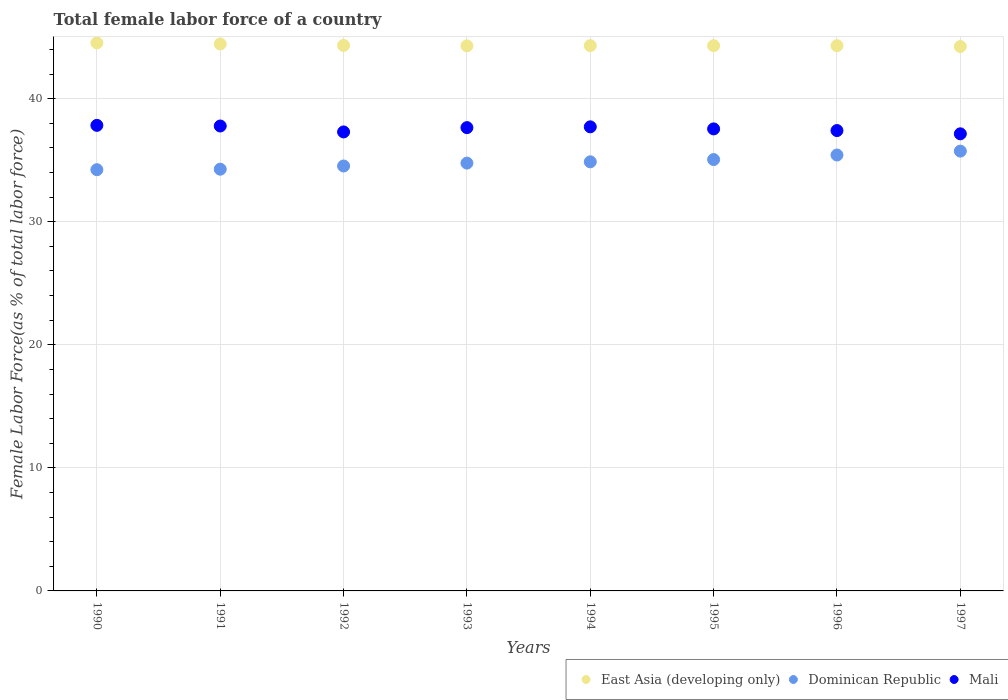How many different coloured dotlines are there?
Provide a succinct answer. 3. Is the number of dotlines equal to the number of legend labels?
Make the answer very short. Yes. What is the percentage of female labor force in East Asia (developing only) in 1993?
Offer a very short reply. 44.29. Across all years, what is the maximum percentage of female labor force in Mali?
Your answer should be very brief. 37.83. Across all years, what is the minimum percentage of female labor force in Mali?
Provide a succinct answer. 37.14. In which year was the percentage of female labor force in Mali minimum?
Your response must be concise. 1997. What is the total percentage of female labor force in Dominican Republic in the graph?
Keep it short and to the point. 278.86. What is the difference between the percentage of female labor force in Mali in 1992 and that in 1996?
Give a very brief answer. -0.11. What is the difference between the percentage of female labor force in East Asia (developing only) in 1991 and the percentage of female labor force in Dominican Republic in 1995?
Provide a short and direct response. 9.39. What is the average percentage of female labor force in Dominican Republic per year?
Your answer should be compact. 34.86. In the year 1996, what is the difference between the percentage of female labor force in Mali and percentage of female labor force in East Asia (developing only)?
Your response must be concise. -6.9. In how many years, is the percentage of female labor force in Dominican Republic greater than 40 %?
Your answer should be compact. 0. What is the ratio of the percentage of female labor force in East Asia (developing only) in 1991 to that in 1995?
Your response must be concise. 1. Is the percentage of female labor force in East Asia (developing only) in 1992 less than that in 1995?
Keep it short and to the point. No. Is the difference between the percentage of female labor force in Mali in 1990 and 1997 greater than the difference between the percentage of female labor force in East Asia (developing only) in 1990 and 1997?
Provide a short and direct response. Yes. What is the difference between the highest and the second highest percentage of female labor force in Mali?
Keep it short and to the point. 0.05. What is the difference between the highest and the lowest percentage of female labor force in Mali?
Give a very brief answer. 0.69. In how many years, is the percentage of female labor force in East Asia (developing only) greater than the average percentage of female labor force in East Asia (developing only) taken over all years?
Give a very brief answer. 2. Is it the case that in every year, the sum of the percentage of female labor force in East Asia (developing only) and percentage of female labor force in Mali  is greater than the percentage of female labor force in Dominican Republic?
Your answer should be compact. Yes. Is the percentage of female labor force in East Asia (developing only) strictly greater than the percentage of female labor force in Mali over the years?
Your answer should be compact. Yes. Is the percentage of female labor force in Mali strictly less than the percentage of female labor force in East Asia (developing only) over the years?
Make the answer very short. Yes. What is the difference between two consecutive major ticks on the Y-axis?
Offer a terse response. 10. Where does the legend appear in the graph?
Provide a short and direct response. Bottom right. How many legend labels are there?
Provide a succinct answer. 3. How are the legend labels stacked?
Offer a terse response. Horizontal. What is the title of the graph?
Provide a short and direct response. Total female labor force of a country. What is the label or title of the Y-axis?
Ensure brevity in your answer.  Female Labor Force(as % of total labor force). What is the Female Labor Force(as % of total labor force) in East Asia (developing only) in 1990?
Your response must be concise. 44.53. What is the Female Labor Force(as % of total labor force) in Dominican Republic in 1990?
Provide a succinct answer. 34.23. What is the Female Labor Force(as % of total labor force) of Mali in 1990?
Your answer should be very brief. 37.83. What is the Female Labor Force(as % of total labor force) of East Asia (developing only) in 1991?
Make the answer very short. 44.44. What is the Female Labor Force(as % of total labor force) of Dominican Republic in 1991?
Your answer should be very brief. 34.27. What is the Female Labor Force(as % of total labor force) of Mali in 1991?
Provide a short and direct response. 37.78. What is the Female Labor Force(as % of total labor force) in East Asia (developing only) in 1992?
Provide a short and direct response. 44.33. What is the Female Labor Force(as % of total labor force) in Dominican Republic in 1992?
Keep it short and to the point. 34.53. What is the Female Labor Force(as % of total labor force) of Mali in 1992?
Offer a very short reply. 37.3. What is the Female Labor Force(as % of total labor force) in East Asia (developing only) in 1993?
Offer a very short reply. 44.29. What is the Female Labor Force(as % of total labor force) in Dominican Republic in 1993?
Make the answer very short. 34.76. What is the Female Labor Force(as % of total labor force) of Mali in 1993?
Offer a terse response. 37.65. What is the Female Labor Force(as % of total labor force) in East Asia (developing only) in 1994?
Keep it short and to the point. 44.31. What is the Female Labor Force(as % of total labor force) of Dominican Republic in 1994?
Provide a short and direct response. 34.87. What is the Female Labor Force(as % of total labor force) in Mali in 1994?
Ensure brevity in your answer.  37.71. What is the Female Labor Force(as % of total labor force) in East Asia (developing only) in 1995?
Keep it short and to the point. 44.3. What is the Female Labor Force(as % of total labor force) in Dominican Republic in 1995?
Your response must be concise. 35.05. What is the Female Labor Force(as % of total labor force) of Mali in 1995?
Offer a very short reply. 37.54. What is the Female Labor Force(as % of total labor force) of East Asia (developing only) in 1996?
Make the answer very short. 44.3. What is the Female Labor Force(as % of total labor force) of Dominican Republic in 1996?
Make the answer very short. 35.42. What is the Female Labor Force(as % of total labor force) of Mali in 1996?
Give a very brief answer. 37.41. What is the Female Labor Force(as % of total labor force) in East Asia (developing only) in 1997?
Provide a succinct answer. 44.24. What is the Female Labor Force(as % of total labor force) of Dominican Republic in 1997?
Provide a short and direct response. 35.74. What is the Female Labor Force(as % of total labor force) in Mali in 1997?
Provide a succinct answer. 37.14. Across all years, what is the maximum Female Labor Force(as % of total labor force) of East Asia (developing only)?
Your answer should be very brief. 44.53. Across all years, what is the maximum Female Labor Force(as % of total labor force) of Dominican Republic?
Make the answer very short. 35.74. Across all years, what is the maximum Female Labor Force(as % of total labor force) in Mali?
Make the answer very short. 37.83. Across all years, what is the minimum Female Labor Force(as % of total labor force) of East Asia (developing only)?
Keep it short and to the point. 44.24. Across all years, what is the minimum Female Labor Force(as % of total labor force) in Dominican Republic?
Provide a short and direct response. 34.23. Across all years, what is the minimum Female Labor Force(as % of total labor force) of Mali?
Give a very brief answer. 37.14. What is the total Female Labor Force(as % of total labor force) of East Asia (developing only) in the graph?
Your answer should be compact. 354.74. What is the total Female Labor Force(as % of total labor force) in Dominican Republic in the graph?
Give a very brief answer. 278.86. What is the total Female Labor Force(as % of total labor force) of Mali in the graph?
Provide a succinct answer. 300.35. What is the difference between the Female Labor Force(as % of total labor force) of East Asia (developing only) in 1990 and that in 1991?
Keep it short and to the point. 0.09. What is the difference between the Female Labor Force(as % of total labor force) in Dominican Republic in 1990 and that in 1991?
Keep it short and to the point. -0.04. What is the difference between the Female Labor Force(as % of total labor force) in Mali in 1990 and that in 1991?
Your response must be concise. 0.05. What is the difference between the Female Labor Force(as % of total labor force) of East Asia (developing only) in 1990 and that in 1992?
Provide a short and direct response. 0.2. What is the difference between the Female Labor Force(as % of total labor force) in Dominican Republic in 1990 and that in 1992?
Your answer should be compact. -0.3. What is the difference between the Female Labor Force(as % of total labor force) of Mali in 1990 and that in 1992?
Your response must be concise. 0.53. What is the difference between the Female Labor Force(as % of total labor force) of East Asia (developing only) in 1990 and that in 1993?
Offer a very short reply. 0.24. What is the difference between the Female Labor Force(as % of total labor force) in Dominican Republic in 1990 and that in 1993?
Ensure brevity in your answer.  -0.54. What is the difference between the Female Labor Force(as % of total labor force) in Mali in 1990 and that in 1993?
Provide a succinct answer. 0.18. What is the difference between the Female Labor Force(as % of total labor force) of East Asia (developing only) in 1990 and that in 1994?
Your answer should be very brief. 0.22. What is the difference between the Female Labor Force(as % of total labor force) of Dominican Republic in 1990 and that in 1994?
Your answer should be compact. -0.64. What is the difference between the Female Labor Force(as % of total labor force) in Mali in 1990 and that in 1994?
Make the answer very short. 0.12. What is the difference between the Female Labor Force(as % of total labor force) of East Asia (developing only) in 1990 and that in 1995?
Provide a short and direct response. 0.23. What is the difference between the Female Labor Force(as % of total labor force) in Dominican Republic in 1990 and that in 1995?
Keep it short and to the point. -0.82. What is the difference between the Female Labor Force(as % of total labor force) of Mali in 1990 and that in 1995?
Your answer should be very brief. 0.29. What is the difference between the Female Labor Force(as % of total labor force) of East Asia (developing only) in 1990 and that in 1996?
Ensure brevity in your answer.  0.23. What is the difference between the Female Labor Force(as % of total labor force) in Dominican Republic in 1990 and that in 1996?
Give a very brief answer. -1.19. What is the difference between the Female Labor Force(as % of total labor force) in Mali in 1990 and that in 1996?
Provide a succinct answer. 0.42. What is the difference between the Female Labor Force(as % of total labor force) of East Asia (developing only) in 1990 and that in 1997?
Keep it short and to the point. 0.29. What is the difference between the Female Labor Force(as % of total labor force) in Dominican Republic in 1990 and that in 1997?
Provide a succinct answer. -1.51. What is the difference between the Female Labor Force(as % of total labor force) in Mali in 1990 and that in 1997?
Offer a very short reply. 0.69. What is the difference between the Female Labor Force(as % of total labor force) in East Asia (developing only) in 1991 and that in 1992?
Give a very brief answer. 0.12. What is the difference between the Female Labor Force(as % of total labor force) in Dominican Republic in 1991 and that in 1992?
Offer a very short reply. -0.26. What is the difference between the Female Labor Force(as % of total labor force) of Mali in 1991 and that in 1992?
Your answer should be very brief. 0.48. What is the difference between the Female Labor Force(as % of total labor force) of East Asia (developing only) in 1991 and that in 1993?
Ensure brevity in your answer.  0.15. What is the difference between the Female Labor Force(as % of total labor force) of Dominican Republic in 1991 and that in 1993?
Your answer should be compact. -0.49. What is the difference between the Female Labor Force(as % of total labor force) of Mali in 1991 and that in 1993?
Give a very brief answer. 0.13. What is the difference between the Female Labor Force(as % of total labor force) of East Asia (developing only) in 1991 and that in 1994?
Provide a short and direct response. 0.13. What is the difference between the Female Labor Force(as % of total labor force) of Dominican Republic in 1991 and that in 1994?
Offer a very short reply. -0.6. What is the difference between the Female Labor Force(as % of total labor force) in Mali in 1991 and that in 1994?
Offer a very short reply. 0.07. What is the difference between the Female Labor Force(as % of total labor force) of East Asia (developing only) in 1991 and that in 1995?
Your response must be concise. 0.14. What is the difference between the Female Labor Force(as % of total labor force) in Dominican Republic in 1991 and that in 1995?
Offer a very short reply. -0.78. What is the difference between the Female Labor Force(as % of total labor force) of Mali in 1991 and that in 1995?
Your answer should be very brief. 0.24. What is the difference between the Female Labor Force(as % of total labor force) of East Asia (developing only) in 1991 and that in 1996?
Provide a short and direct response. 0.14. What is the difference between the Female Labor Force(as % of total labor force) in Dominican Republic in 1991 and that in 1996?
Provide a succinct answer. -1.15. What is the difference between the Female Labor Force(as % of total labor force) in Mali in 1991 and that in 1996?
Give a very brief answer. 0.37. What is the difference between the Female Labor Force(as % of total labor force) in East Asia (developing only) in 1991 and that in 1997?
Your answer should be compact. 0.2. What is the difference between the Female Labor Force(as % of total labor force) of Dominican Republic in 1991 and that in 1997?
Provide a short and direct response. -1.47. What is the difference between the Female Labor Force(as % of total labor force) of Mali in 1991 and that in 1997?
Make the answer very short. 0.63. What is the difference between the Female Labor Force(as % of total labor force) of East Asia (developing only) in 1992 and that in 1993?
Ensure brevity in your answer.  0.04. What is the difference between the Female Labor Force(as % of total labor force) in Dominican Republic in 1992 and that in 1993?
Keep it short and to the point. -0.23. What is the difference between the Female Labor Force(as % of total labor force) of Mali in 1992 and that in 1993?
Your answer should be compact. -0.35. What is the difference between the Female Labor Force(as % of total labor force) of East Asia (developing only) in 1992 and that in 1994?
Give a very brief answer. 0.02. What is the difference between the Female Labor Force(as % of total labor force) in Dominican Republic in 1992 and that in 1994?
Ensure brevity in your answer.  -0.34. What is the difference between the Female Labor Force(as % of total labor force) of Mali in 1992 and that in 1994?
Your answer should be compact. -0.41. What is the difference between the Female Labor Force(as % of total labor force) of East Asia (developing only) in 1992 and that in 1995?
Your answer should be very brief. 0.02. What is the difference between the Female Labor Force(as % of total labor force) of Dominican Republic in 1992 and that in 1995?
Offer a terse response. -0.52. What is the difference between the Female Labor Force(as % of total labor force) in Mali in 1992 and that in 1995?
Make the answer very short. -0.25. What is the difference between the Female Labor Force(as % of total labor force) of East Asia (developing only) in 1992 and that in 1996?
Offer a very short reply. 0.02. What is the difference between the Female Labor Force(as % of total labor force) in Dominican Republic in 1992 and that in 1996?
Make the answer very short. -0.89. What is the difference between the Female Labor Force(as % of total labor force) in Mali in 1992 and that in 1996?
Offer a very short reply. -0.11. What is the difference between the Female Labor Force(as % of total labor force) of East Asia (developing only) in 1992 and that in 1997?
Ensure brevity in your answer.  0.09. What is the difference between the Female Labor Force(as % of total labor force) of Dominican Republic in 1992 and that in 1997?
Keep it short and to the point. -1.21. What is the difference between the Female Labor Force(as % of total labor force) of Mali in 1992 and that in 1997?
Ensure brevity in your answer.  0.15. What is the difference between the Female Labor Force(as % of total labor force) in East Asia (developing only) in 1993 and that in 1994?
Your answer should be compact. -0.02. What is the difference between the Female Labor Force(as % of total labor force) of Dominican Republic in 1993 and that in 1994?
Your answer should be very brief. -0.1. What is the difference between the Female Labor Force(as % of total labor force) of Mali in 1993 and that in 1994?
Your response must be concise. -0.06. What is the difference between the Female Labor Force(as % of total labor force) of East Asia (developing only) in 1993 and that in 1995?
Keep it short and to the point. -0.01. What is the difference between the Female Labor Force(as % of total labor force) of Dominican Republic in 1993 and that in 1995?
Your answer should be compact. -0.29. What is the difference between the Female Labor Force(as % of total labor force) of Mali in 1993 and that in 1995?
Ensure brevity in your answer.  0.1. What is the difference between the Female Labor Force(as % of total labor force) of East Asia (developing only) in 1993 and that in 1996?
Provide a succinct answer. -0.01. What is the difference between the Female Labor Force(as % of total labor force) in Dominican Republic in 1993 and that in 1996?
Provide a short and direct response. -0.66. What is the difference between the Female Labor Force(as % of total labor force) in Mali in 1993 and that in 1996?
Give a very brief answer. 0.24. What is the difference between the Female Labor Force(as % of total labor force) of East Asia (developing only) in 1993 and that in 1997?
Your answer should be very brief. 0.05. What is the difference between the Female Labor Force(as % of total labor force) of Dominican Republic in 1993 and that in 1997?
Your answer should be very brief. -0.97. What is the difference between the Female Labor Force(as % of total labor force) of Mali in 1993 and that in 1997?
Your response must be concise. 0.5. What is the difference between the Female Labor Force(as % of total labor force) in East Asia (developing only) in 1994 and that in 1995?
Ensure brevity in your answer.  0. What is the difference between the Female Labor Force(as % of total labor force) in Dominican Republic in 1994 and that in 1995?
Offer a terse response. -0.18. What is the difference between the Female Labor Force(as % of total labor force) of Mali in 1994 and that in 1995?
Your response must be concise. 0.17. What is the difference between the Female Labor Force(as % of total labor force) in East Asia (developing only) in 1994 and that in 1996?
Offer a very short reply. 0.01. What is the difference between the Female Labor Force(as % of total labor force) in Dominican Republic in 1994 and that in 1996?
Provide a short and direct response. -0.55. What is the difference between the Female Labor Force(as % of total labor force) in Mali in 1994 and that in 1996?
Provide a short and direct response. 0.3. What is the difference between the Female Labor Force(as % of total labor force) of East Asia (developing only) in 1994 and that in 1997?
Your answer should be compact. 0.07. What is the difference between the Female Labor Force(as % of total labor force) in Dominican Republic in 1994 and that in 1997?
Your answer should be compact. -0.87. What is the difference between the Female Labor Force(as % of total labor force) of Mali in 1994 and that in 1997?
Your answer should be compact. 0.57. What is the difference between the Female Labor Force(as % of total labor force) in East Asia (developing only) in 1995 and that in 1996?
Your answer should be compact. 0. What is the difference between the Female Labor Force(as % of total labor force) of Dominican Republic in 1995 and that in 1996?
Make the answer very short. -0.37. What is the difference between the Female Labor Force(as % of total labor force) in Mali in 1995 and that in 1996?
Your response must be concise. 0.14. What is the difference between the Female Labor Force(as % of total labor force) of East Asia (developing only) in 1995 and that in 1997?
Give a very brief answer. 0.07. What is the difference between the Female Labor Force(as % of total labor force) in Dominican Republic in 1995 and that in 1997?
Make the answer very short. -0.69. What is the difference between the Female Labor Force(as % of total labor force) of Mali in 1995 and that in 1997?
Make the answer very short. 0.4. What is the difference between the Female Labor Force(as % of total labor force) of East Asia (developing only) in 1996 and that in 1997?
Provide a succinct answer. 0.07. What is the difference between the Female Labor Force(as % of total labor force) in Dominican Republic in 1996 and that in 1997?
Your answer should be very brief. -0.32. What is the difference between the Female Labor Force(as % of total labor force) in Mali in 1996 and that in 1997?
Make the answer very short. 0.26. What is the difference between the Female Labor Force(as % of total labor force) of East Asia (developing only) in 1990 and the Female Labor Force(as % of total labor force) of Dominican Republic in 1991?
Your answer should be very brief. 10.26. What is the difference between the Female Labor Force(as % of total labor force) in East Asia (developing only) in 1990 and the Female Labor Force(as % of total labor force) in Mali in 1991?
Keep it short and to the point. 6.75. What is the difference between the Female Labor Force(as % of total labor force) of Dominican Republic in 1990 and the Female Labor Force(as % of total labor force) of Mali in 1991?
Your response must be concise. -3.55. What is the difference between the Female Labor Force(as % of total labor force) in East Asia (developing only) in 1990 and the Female Labor Force(as % of total labor force) in Dominican Republic in 1992?
Ensure brevity in your answer.  10. What is the difference between the Female Labor Force(as % of total labor force) of East Asia (developing only) in 1990 and the Female Labor Force(as % of total labor force) of Mali in 1992?
Your response must be concise. 7.23. What is the difference between the Female Labor Force(as % of total labor force) of Dominican Republic in 1990 and the Female Labor Force(as % of total labor force) of Mali in 1992?
Provide a short and direct response. -3.07. What is the difference between the Female Labor Force(as % of total labor force) of East Asia (developing only) in 1990 and the Female Labor Force(as % of total labor force) of Dominican Republic in 1993?
Give a very brief answer. 9.77. What is the difference between the Female Labor Force(as % of total labor force) of East Asia (developing only) in 1990 and the Female Labor Force(as % of total labor force) of Mali in 1993?
Provide a short and direct response. 6.88. What is the difference between the Female Labor Force(as % of total labor force) of Dominican Republic in 1990 and the Female Labor Force(as % of total labor force) of Mali in 1993?
Keep it short and to the point. -3.42. What is the difference between the Female Labor Force(as % of total labor force) in East Asia (developing only) in 1990 and the Female Labor Force(as % of total labor force) in Dominican Republic in 1994?
Offer a very short reply. 9.66. What is the difference between the Female Labor Force(as % of total labor force) of East Asia (developing only) in 1990 and the Female Labor Force(as % of total labor force) of Mali in 1994?
Offer a very short reply. 6.82. What is the difference between the Female Labor Force(as % of total labor force) in Dominican Republic in 1990 and the Female Labor Force(as % of total labor force) in Mali in 1994?
Your answer should be compact. -3.48. What is the difference between the Female Labor Force(as % of total labor force) of East Asia (developing only) in 1990 and the Female Labor Force(as % of total labor force) of Dominican Republic in 1995?
Keep it short and to the point. 9.48. What is the difference between the Female Labor Force(as % of total labor force) in East Asia (developing only) in 1990 and the Female Labor Force(as % of total labor force) in Mali in 1995?
Provide a short and direct response. 6.99. What is the difference between the Female Labor Force(as % of total labor force) of Dominican Republic in 1990 and the Female Labor Force(as % of total labor force) of Mali in 1995?
Ensure brevity in your answer.  -3.32. What is the difference between the Female Labor Force(as % of total labor force) of East Asia (developing only) in 1990 and the Female Labor Force(as % of total labor force) of Dominican Republic in 1996?
Ensure brevity in your answer.  9.11. What is the difference between the Female Labor Force(as % of total labor force) in East Asia (developing only) in 1990 and the Female Labor Force(as % of total labor force) in Mali in 1996?
Ensure brevity in your answer.  7.12. What is the difference between the Female Labor Force(as % of total labor force) of Dominican Republic in 1990 and the Female Labor Force(as % of total labor force) of Mali in 1996?
Provide a short and direct response. -3.18. What is the difference between the Female Labor Force(as % of total labor force) of East Asia (developing only) in 1990 and the Female Labor Force(as % of total labor force) of Dominican Republic in 1997?
Provide a succinct answer. 8.79. What is the difference between the Female Labor Force(as % of total labor force) of East Asia (developing only) in 1990 and the Female Labor Force(as % of total labor force) of Mali in 1997?
Provide a succinct answer. 7.39. What is the difference between the Female Labor Force(as % of total labor force) of Dominican Republic in 1990 and the Female Labor Force(as % of total labor force) of Mali in 1997?
Provide a short and direct response. -2.92. What is the difference between the Female Labor Force(as % of total labor force) in East Asia (developing only) in 1991 and the Female Labor Force(as % of total labor force) in Dominican Republic in 1992?
Provide a succinct answer. 9.91. What is the difference between the Female Labor Force(as % of total labor force) of East Asia (developing only) in 1991 and the Female Labor Force(as % of total labor force) of Mali in 1992?
Keep it short and to the point. 7.15. What is the difference between the Female Labor Force(as % of total labor force) of Dominican Republic in 1991 and the Female Labor Force(as % of total labor force) of Mali in 1992?
Your response must be concise. -3.03. What is the difference between the Female Labor Force(as % of total labor force) of East Asia (developing only) in 1991 and the Female Labor Force(as % of total labor force) of Dominican Republic in 1993?
Your answer should be compact. 9.68. What is the difference between the Female Labor Force(as % of total labor force) in East Asia (developing only) in 1991 and the Female Labor Force(as % of total labor force) in Mali in 1993?
Provide a succinct answer. 6.8. What is the difference between the Female Labor Force(as % of total labor force) of Dominican Republic in 1991 and the Female Labor Force(as % of total labor force) of Mali in 1993?
Your answer should be very brief. -3.38. What is the difference between the Female Labor Force(as % of total labor force) in East Asia (developing only) in 1991 and the Female Labor Force(as % of total labor force) in Dominican Republic in 1994?
Your response must be concise. 9.57. What is the difference between the Female Labor Force(as % of total labor force) of East Asia (developing only) in 1991 and the Female Labor Force(as % of total labor force) of Mali in 1994?
Offer a terse response. 6.73. What is the difference between the Female Labor Force(as % of total labor force) in Dominican Republic in 1991 and the Female Labor Force(as % of total labor force) in Mali in 1994?
Provide a short and direct response. -3.44. What is the difference between the Female Labor Force(as % of total labor force) of East Asia (developing only) in 1991 and the Female Labor Force(as % of total labor force) of Dominican Republic in 1995?
Make the answer very short. 9.39. What is the difference between the Female Labor Force(as % of total labor force) in East Asia (developing only) in 1991 and the Female Labor Force(as % of total labor force) in Mali in 1995?
Offer a very short reply. 6.9. What is the difference between the Female Labor Force(as % of total labor force) in Dominican Republic in 1991 and the Female Labor Force(as % of total labor force) in Mali in 1995?
Ensure brevity in your answer.  -3.27. What is the difference between the Female Labor Force(as % of total labor force) in East Asia (developing only) in 1991 and the Female Labor Force(as % of total labor force) in Dominican Republic in 1996?
Your answer should be compact. 9.02. What is the difference between the Female Labor Force(as % of total labor force) in East Asia (developing only) in 1991 and the Female Labor Force(as % of total labor force) in Mali in 1996?
Give a very brief answer. 7.03. What is the difference between the Female Labor Force(as % of total labor force) of Dominican Republic in 1991 and the Female Labor Force(as % of total labor force) of Mali in 1996?
Offer a very short reply. -3.14. What is the difference between the Female Labor Force(as % of total labor force) in East Asia (developing only) in 1991 and the Female Labor Force(as % of total labor force) in Dominican Republic in 1997?
Offer a very short reply. 8.7. What is the difference between the Female Labor Force(as % of total labor force) in East Asia (developing only) in 1991 and the Female Labor Force(as % of total labor force) in Mali in 1997?
Make the answer very short. 7.3. What is the difference between the Female Labor Force(as % of total labor force) of Dominican Republic in 1991 and the Female Labor Force(as % of total labor force) of Mali in 1997?
Provide a succinct answer. -2.87. What is the difference between the Female Labor Force(as % of total labor force) in East Asia (developing only) in 1992 and the Female Labor Force(as % of total labor force) in Dominican Republic in 1993?
Offer a very short reply. 9.56. What is the difference between the Female Labor Force(as % of total labor force) of East Asia (developing only) in 1992 and the Female Labor Force(as % of total labor force) of Mali in 1993?
Offer a very short reply. 6.68. What is the difference between the Female Labor Force(as % of total labor force) of Dominican Republic in 1992 and the Female Labor Force(as % of total labor force) of Mali in 1993?
Your answer should be compact. -3.12. What is the difference between the Female Labor Force(as % of total labor force) in East Asia (developing only) in 1992 and the Female Labor Force(as % of total labor force) in Dominican Republic in 1994?
Provide a short and direct response. 9.46. What is the difference between the Female Labor Force(as % of total labor force) of East Asia (developing only) in 1992 and the Female Labor Force(as % of total labor force) of Mali in 1994?
Your answer should be compact. 6.62. What is the difference between the Female Labor Force(as % of total labor force) in Dominican Republic in 1992 and the Female Labor Force(as % of total labor force) in Mali in 1994?
Keep it short and to the point. -3.18. What is the difference between the Female Labor Force(as % of total labor force) of East Asia (developing only) in 1992 and the Female Labor Force(as % of total labor force) of Dominican Republic in 1995?
Give a very brief answer. 9.28. What is the difference between the Female Labor Force(as % of total labor force) in East Asia (developing only) in 1992 and the Female Labor Force(as % of total labor force) in Mali in 1995?
Keep it short and to the point. 6.78. What is the difference between the Female Labor Force(as % of total labor force) in Dominican Republic in 1992 and the Female Labor Force(as % of total labor force) in Mali in 1995?
Offer a very short reply. -3.01. What is the difference between the Female Labor Force(as % of total labor force) in East Asia (developing only) in 1992 and the Female Labor Force(as % of total labor force) in Dominican Republic in 1996?
Give a very brief answer. 8.91. What is the difference between the Female Labor Force(as % of total labor force) of East Asia (developing only) in 1992 and the Female Labor Force(as % of total labor force) of Mali in 1996?
Provide a succinct answer. 6.92. What is the difference between the Female Labor Force(as % of total labor force) of Dominican Republic in 1992 and the Female Labor Force(as % of total labor force) of Mali in 1996?
Give a very brief answer. -2.88. What is the difference between the Female Labor Force(as % of total labor force) in East Asia (developing only) in 1992 and the Female Labor Force(as % of total labor force) in Dominican Republic in 1997?
Keep it short and to the point. 8.59. What is the difference between the Female Labor Force(as % of total labor force) of East Asia (developing only) in 1992 and the Female Labor Force(as % of total labor force) of Mali in 1997?
Keep it short and to the point. 7.18. What is the difference between the Female Labor Force(as % of total labor force) in Dominican Republic in 1992 and the Female Labor Force(as % of total labor force) in Mali in 1997?
Give a very brief answer. -2.62. What is the difference between the Female Labor Force(as % of total labor force) of East Asia (developing only) in 1993 and the Female Labor Force(as % of total labor force) of Dominican Republic in 1994?
Offer a terse response. 9.42. What is the difference between the Female Labor Force(as % of total labor force) in East Asia (developing only) in 1993 and the Female Labor Force(as % of total labor force) in Mali in 1994?
Offer a terse response. 6.58. What is the difference between the Female Labor Force(as % of total labor force) of Dominican Republic in 1993 and the Female Labor Force(as % of total labor force) of Mali in 1994?
Make the answer very short. -2.95. What is the difference between the Female Labor Force(as % of total labor force) of East Asia (developing only) in 1993 and the Female Labor Force(as % of total labor force) of Dominican Republic in 1995?
Offer a terse response. 9.24. What is the difference between the Female Labor Force(as % of total labor force) of East Asia (developing only) in 1993 and the Female Labor Force(as % of total labor force) of Mali in 1995?
Offer a very short reply. 6.75. What is the difference between the Female Labor Force(as % of total labor force) in Dominican Republic in 1993 and the Female Labor Force(as % of total labor force) in Mali in 1995?
Provide a short and direct response. -2.78. What is the difference between the Female Labor Force(as % of total labor force) of East Asia (developing only) in 1993 and the Female Labor Force(as % of total labor force) of Dominican Republic in 1996?
Provide a succinct answer. 8.87. What is the difference between the Female Labor Force(as % of total labor force) in East Asia (developing only) in 1993 and the Female Labor Force(as % of total labor force) in Mali in 1996?
Provide a succinct answer. 6.88. What is the difference between the Female Labor Force(as % of total labor force) in Dominican Republic in 1993 and the Female Labor Force(as % of total labor force) in Mali in 1996?
Offer a terse response. -2.64. What is the difference between the Female Labor Force(as % of total labor force) in East Asia (developing only) in 1993 and the Female Labor Force(as % of total labor force) in Dominican Republic in 1997?
Make the answer very short. 8.55. What is the difference between the Female Labor Force(as % of total labor force) of East Asia (developing only) in 1993 and the Female Labor Force(as % of total labor force) of Mali in 1997?
Your answer should be very brief. 7.15. What is the difference between the Female Labor Force(as % of total labor force) in Dominican Republic in 1993 and the Female Labor Force(as % of total labor force) in Mali in 1997?
Your answer should be very brief. -2.38. What is the difference between the Female Labor Force(as % of total labor force) in East Asia (developing only) in 1994 and the Female Labor Force(as % of total labor force) in Dominican Republic in 1995?
Offer a very short reply. 9.26. What is the difference between the Female Labor Force(as % of total labor force) in East Asia (developing only) in 1994 and the Female Labor Force(as % of total labor force) in Mali in 1995?
Your answer should be very brief. 6.77. What is the difference between the Female Labor Force(as % of total labor force) of Dominican Republic in 1994 and the Female Labor Force(as % of total labor force) of Mali in 1995?
Give a very brief answer. -2.68. What is the difference between the Female Labor Force(as % of total labor force) of East Asia (developing only) in 1994 and the Female Labor Force(as % of total labor force) of Dominican Republic in 1996?
Your answer should be very brief. 8.89. What is the difference between the Female Labor Force(as % of total labor force) in East Asia (developing only) in 1994 and the Female Labor Force(as % of total labor force) in Mali in 1996?
Offer a very short reply. 6.9. What is the difference between the Female Labor Force(as % of total labor force) in Dominican Republic in 1994 and the Female Labor Force(as % of total labor force) in Mali in 1996?
Offer a very short reply. -2.54. What is the difference between the Female Labor Force(as % of total labor force) in East Asia (developing only) in 1994 and the Female Labor Force(as % of total labor force) in Dominican Republic in 1997?
Provide a short and direct response. 8.57. What is the difference between the Female Labor Force(as % of total labor force) of East Asia (developing only) in 1994 and the Female Labor Force(as % of total labor force) of Mali in 1997?
Give a very brief answer. 7.17. What is the difference between the Female Labor Force(as % of total labor force) of Dominican Republic in 1994 and the Female Labor Force(as % of total labor force) of Mali in 1997?
Your response must be concise. -2.28. What is the difference between the Female Labor Force(as % of total labor force) in East Asia (developing only) in 1995 and the Female Labor Force(as % of total labor force) in Dominican Republic in 1996?
Keep it short and to the point. 8.88. What is the difference between the Female Labor Force(as % of total labor force) in East Asia (developing only) in 1995 and the Female Labor Force(as % of total labor force) in Mali in 1996?
Ensure brevity in your answer.  6.9. What is the difference between the Female Labor Force(as % of total labor force) in Dominican Republic in 1995 and the Female Labor Force(as % of total labor force) in Mali in 1996?
Ensure brevity in your answer.  -2.36. What is the difference between the Female Labor Force(as % of total labor force) in East Asia (developing only) in 1995 and the Female Labor Force(as % of total labor force) in Dominican Republic in 1997?
Your answer should be compact. 8.57. What is the difference between the Female Labor Force(as % of total labor force) of East Asia (developing only) in 1995 and the Female Labor Force(as % of total labor force) of Mali in 1997?
Offer a very short reply. 7.16. What is the difference between the Female Labor Force(as % of total labor force) of Dominican Republic in 1995 and the Female Labor Force(as % of total labor force) of Mali in 1997?
Your answer should be very brief. -2.09. What is the difference between the Female Labor Force(as % of total labor force) in East Asia (developing only) in 1996 and the Female Labor Force(as % of total labor force) in Dominican Republic in 1997?
Make the answer very short. 8.57. What is the difference between the Female Labor Force(as % of total labor force) in East Asia (developing only) in 1996 and the Female Labor Force(as % of total labor force) in Mali in 1997?
Keep it short and to the point. 7.16. What is the difference between the Female Labor Force(as % of total labor force) of Dominican Republic in 1996 and the Female Labor Force(as % of total labor force) of Mali in 1997?
Ensure brevity in your answer.  -1.72. What is the average Female Labor Force(as % of total labor force) of East Asia (developing only) per year?
Your answer should be very brief. 44.34. What is the average Female Labor Force(as % of total labor force) in Dominican Republic per year?
Your answer should be very brief. 34.86. What is the average Female Labor Force(as % of total labor force) of Mali per year?
Ensure brevity in your answer.  37.54. In the year 1990, what is the difference between the Female Labor Force(as % of total labor force) of East Asia (developing only) and Female Labor Force(as % of total labor force) of Dominican Republic?
Offer a very short reply. 10.3. In the year 1990, what is the difference between the Female Labor Force(as % of total labor force) in East Asia (developing only) and Female Labor Force(as % of total labor force) in Mali?
Ensure brevity in your answer.  6.7. In the year 1990, what is the difference between the Female Labor Force(as % of total labor force) of Dominican Republic and Female Labor Force(as % of total labor force) of Mali?
Ensure brevity in your answer.  -3.6. In the year 1991, what is the difference between the Female Labor Force(as % of total labor force) of East Asia (developing only) and Female Labor Force(as % of total labor force) of Dominican Republic?
Offer a terse response. 10.17. In the year 1991, what is the difference between the Female Labor Force(as % of total labor force) in East Asia (developing only) and Female Labor Force(as % of total labor force) in Mali?
Keep it short and to the point. 6.66. In the year 1991, what is the difference between the Female Labor Force(as % of total labor force) of Dominican Republic and Female Labor Force(as % of total labor force) of Mali?
Ensure brevity in your answer.  -3.51. In the year 1992, what is the difference between the Female Labor Force(as % of total labor force) of East Asia (developing only) and Female Labor Force(as % of total labor force) of Dominican Republic?
Keep it short and to the point. 9.8. In the year 1992, what is the difference between the Female Labor Force(as % of total labor force) of East Asia (developing only) and Female Labor Force(as % of total labor force) of Mali?
Keep it short and to the point. 7.03. In the year 1992, what is the difference between the Female Labor Force(as % of total labor force) of Dominican Republic and Female Labor Force(as % of total labor force) of Mali?
Offer a very short reply. -2.77. In the year 1993, what is the difference between the Female Labor Force(as % of total labor force) in East Asia (developing only) and Female Labor Force(as % of total labor force) in Dominican Republic?
Provide a short and direct response. 9.53. In the year 1993, what is the difference between the Female Labor Force(as % of total labor force) of East Asia (developing only) and Female Labor Force(as % of total labor force) of Mali?
Your response must be concise. 6.64. In the year 1993, what is the difference between the Female Labor Force(as % of total labor force) of Dominican Republic and Female Labor Force(as % of total labor force) of Mali?
Provide a succinct answer. -2.88. In the year 1994, what is the difference between the Female Labor Force(as % of total labor force) of East Asia (developing only) and Female Labor Force(as % of total labor force) of Dominican Republic?
Offer a very short reply. 9.44. In the year 1994, what is the difference between the Female Labor Force(as % of total labor force) of East Asia (developing only) and Female Labor Force(as % of total labor force) of Mali?
Give a very brief answer. 6.6. In the year 1994, what is the difference between the Female Labor Force(as % of total labor force) of Dominican Republic and Female Labor Force(as % of total labor force) of Mali?
Keep it short and to the point. -2.84. In the year 1995, what is the difference between the Female Labor Force(as % of total labor force) of East Asia (developing only) and Female Labor Force(as % of total labor force) of Dominican Republic?
Your answer should be very brief. 9.25. In the year 1995, what is the difference between the Female Labor Force(as % of total labor force) of East Asia (developing only) and Female Labor Force(as % of total labor force) of Mali?
Your answer should be very brief. 6.76. In the year 1995, what is the difference between the Female Labor Force(as % of total labor force) of Dominican Republic and Female Labor Force(as % of total labor force) of Mali?
Make the answer very short. -2.49. In the year 1996, what is the difference between the Female Labor Force(as % of total labor force) in East Asia (developing only) and Female Labor Force(as % of total labor force) in Dominican Republic?
Your answer should be compact. 8.88. In the year 1996, what is the difference between the Female Labor Force(as % of total labor force) in East Asia (developing only) and Female Labor Force(as % of total labor force) in Mali?
Offer a terse response. 6.9. In the year 1996, what is the difference between the Female Labor Force(as % of total labor force) in Dominican Republic and Female Labor Force(as % of total labor force) in Mali?
Your answer should be compact. -1.99. In the year 1997, what is the difference between the Female Labor Force(as % of total labor force) of East Asia (developing only) and Female Labor Force(as % of total labor force) of Dominican Republic?
Offer a very short reply. 8.5. In the year 1997, what is the difference between the Female Labor Force(as % of total labor force) in East Asia (developing only) and Female Labor Force(as % of total labor force) in Mali?
Your response must be concise. 7.09. In the year 1997, what is the difference between the Female Labor Force(as % of total labor force) in Dominican Republic and Female Labor Force(as % of total labor force) in Mali?
Your answer should be compact. -1.41. What is the ratio of the Female Labor Force(as % of total labor force) of Dominican Republic in 1990 to that in 1991?
Provide a short and direct response. 1. What is the ratio of the Female Labor Force(as % of total labor force) of Mali in 1990 to that in 1991?
Provide a short and direct response. 1. What is the ratio of the Female Labor Force(as % of total labor force) in East Asia (developing only) in 1990 to that in 1992?
Your answer should be very brief. 1. What is the ratio of the Female Labor Force(as % of total labor force) of Mali in 1990 to that in 1992?
Make the answer very short. 1.01. What is the ratio of the Female Labor Force(as % of total labor force) in East Asia (developing only) in 1990 to that in 1993?
Make the answer very short. 1.01. What is the ratio of the Female Labor Force(as % of total labor force) in Dominican Republic in 1990 to that in 1993?
Provide a short and direct response. 0.98. What is the ratio of the Female Labor Force(as % of total labor force) of Dominican Republic in 1990 to that in 1994?
Provide a succinct answer. 0.98. What is the ratio of the Female Labor Force(as % of total labor force) of Mali in 1990 to that in 1994?
Give a very brief answer. 1. What is the ratio of the Female Labor Force(as % of total labor force) in Dominican Republic in 1990 to that in 1995?
Your response must be concise. 0.98. What is the ratio of the Female Labor Force(as % of total labor force) of Mali in 1990 to that in 1995?
Provide a succinct answer. 1.01. What is the ratio of the Female Labor Force(as % of total labor force) in East Asia (developing only) in 1990 to that in 1996?
Give a very brief answer. 1.01. What is the ratio of the Female Labor Force(as % of total labor force) in Dominican Republic in 1990 to that in 1996?
Your response must be concise. 0.97. What is the ratio of the Female Labor Force(as % of total labor force) in Mali in 1990 to that in 1996?
Provide a succinct answer. 1.01. What is the ratio of the Female Labor Force(as % of total labor force) in East Asia (developing only) in 1990 to that in 1997?
Offer a very short reply. 1.01. What is the ratio of the Female Labor Force(as % of total labor force) of Dominican Republic in 1990 to that in 1997?
Your answer should be compact. 0.96. What is the ratio of the Female Labor Force(as % of total labor force) in Mali in 1990 to that in 1997?
Ensure brevity in your answer.  1.02. What is the ratio of the Female Labor Force(as % of total labor force) of Mali in 1991 to that in 1992?
Provide a short and direct response. 1.01. What is the ratio of the Female Labor Force(as % of total labor force) of Dominican Republic in 1991 to that in 1993?
Make the answer very short. 0.99. What is the ratio of the Female Labor Force(as % of total labor force) in Dominican Republic in 1991 to that in 1994?
Your answer should be compact. 0.98. What is the ratio of the Female Labor Force(as % of total labor force) of Dominican Republic in 1991 to that in 1995?
Keep it short and to the point. 0.98. What is the ratio of the Female Labor Force(as % of total labor force) in East Asia (developing only) in 1991 to that in 1996?
Provide a succinct answer. 1. What is the ratio of the Female Labor Force(as % of total labor force) in Dominican Republic in 1991 to that in 1996?
Offer a very short reply. 0.97. What is the ratio of the Female Labor Force(as % of total labor force) in Mali in 1991 to that in 1996?
Your answer should be very brief. 1.01. What is the ratio of the Female Labor Force(as % of total labor force) in East Asia (developing only) in 1991 to that in 1997?
Give a very brief answer. 1. What is the ratio of the Female Labor Force(as % of total labor force) of Dominican Republic in 1991 to that in 1997?
Provide a short and direct response. 0.96. What is the ratio of the Female Labor Force(as % of total labor force) in Mali in 1991 to that in 1997?
Offer a terse response. 1.02. What is the ratio of the Female Labor Force(as % of total labor force) of Mali in 1992 to that in 1993?
Provide a short and direct response. 0.99. What is the ratio of the Female Labor Force(as % of total labor force) in Dominican Republic in 1992 to that in 1994?
Your answer should be very brief. 0.99. What is the ratio of the Female Labor Force(as % of total labor force) in Mali in 1992 to that in 1994?
Provide a succinct answer. 0.99. What is the ratio of the Female Labor Force(as % of total labor force) of East Asia (developing only) in 1992 to that in 1995?
Your answer should be compact. 1. What is the ratio of the Female Labor Force(as % of total labor force) in Dominican Republic in 1992 to that in 1995?
Your response must be concise. 0.99. What is the ratio of the Female Labor Force(as % of total labor force) of Mali in 1992 to that in 1995?
Offer a terse response. 0.99. What is the ratio of the Female Labor Force(as % of total labor force) of Dominican Republic in 1992 to that in 1996?
Make the answer very short. 0.97. What is the ratio of the Female Labor Force(as % of total labor force) of Mali in 1992 to that in 1996?
Your answer should be very brief. 1. What is the ratio of the Female Labor Force(as % of total labor force) of East Asia (developing only) in 1992 to that in 1997?
Your answer should be compact. 1. What is the ratio of the Female Labor Force(as % of total labor force) in Dominican Republic in 1992 to that in 1997?
Ensure brevity in your answer.  0.97. What is the ratio of the Female Labor Force(as % of total labor force) in Dominican Republic in 1993 to that in 1994?
Your response must be concise. 1. What is the ratio of the Female Labor Force(as % of total labor force) in East Asia (developing only) in 1993 to that in 1995?
Your answer should be very brief. 1. What is the ratio of the Female Labor Force(as % of total labor force) in Dominican Republic in 1993 to that in 1995?
Provide a succinct answer. 0.99. What is the ratio of the Female Labor Force(as % of total labor force) in East Asia (developing only) in 1993 to that in 1996?
Your answer should be very brief. 1. What is the ratio of the Female Labor Force(as % of total labor force) in Dominican Republic in 1993 to that in 1996?
Ensure brevity in your answer.  0.98. What is the ratio of the Female Labor Force(as % of total labor force) in Mali in 1993 to that in 1996?
Ensure brevity in your answer.  1.01. What is the ratio of the Female Labor Force(as % of total labor force) in Dominican Republic in 1993 to that in 1997?
Keep it short and to the point. 0.97. What is the ratio of the Female Labor Force(as % of total labor force) of Mali in 1993 to that in 1997?
Your answer should be compact. 1.01. What is the ratio of the Female Labor Force(as % of total labor force) of East Asia (developing only) in 1994 to that in 1995?
Offer a very short reply. 1. What is the ratio of the Female Labor Force(as % of total labor force) in Dominican Republic in 1994 to that in 1995?
Offer a terse response. 0.99. What is the ratio of the Female Labor Force(as % of total labor force) in Dominican Republic in 1994 to that in 1996?
Your answer should be compact. 0.98. What is the ratio of the Female Labor Force(as % of total labor force) of Dominican Republic in 1994 to that in 1997?
Your answer should be compact. 0.98. What is the ratio of the Female Labor Force(as % of total labor force) of Mali in 1994 to that in 1997?
Give a very brief answer. 1.02. What is the ratio of the Female Labor Force(as % of total labor force) in Dominican Republic in 1995 to that in 1997?
Provide a short and direct response. 0.98. What is the ratio of the Female Labor Force(as % of total labor force) of Mali in 1995 to that in 1997?
Provide a succinct answer. 1.01. What is the ratio of the Female Labor Force(as % of total labor force) in East Asia (developing only) in 1996 to that in 1997?
Your response must be concise. 1. What is the ratio of the Female Labor Force(as % of total labor force) of Dominican Republic in 1996 to that in 1997?
Keep it short and to the point. 0.99. What is the ratio of the Female Labor Force(as % of total labor force) of Mali in 1996 to that in 1997?
Make the answer very short. 1.01. What is the difference between the highest and the second highest Female Labor Force(as % of total labor force) in East Asia (developing only)?
Offer a terse response. 0.09. What is the difference between the highest and the second highest Female Labor Force(as % of total labor force) of Dominican Republic?
Provide a succinct answer. 0.32. What is the difference between the highest and the second highest Female Labor Force(as % of total labor force) of Mali?
Make the answer very short. 0.05. What is the difference between the highest and the lowest Female Labor Force(as % of total labor force) of East Asia (developing only)?
Offer a terse response. 0.29. What is the difference between the highest and the lowest Female Labor Force(as % of total labor force) of Dominican Republic?
Offer a very short reply. 1.51. What is the difference between the highest and the lowest Female Labor Force(as % of total labor force) of Mali?
Keep it short and to the point. 0.69. 